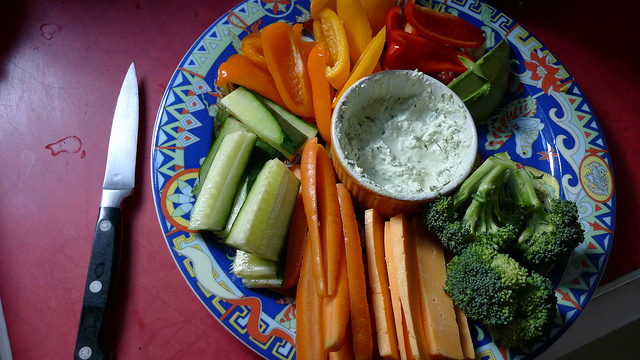Are these vegetables considered a healthy snack option? Absolutely, the vegetables shown are fresh and nutrient-rich, making them an excellent choice for a healthy snack. They provide essential vitamins and minerals, fiber, and are low in calories. 